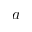Convert formula to latex. <formula><loc_0><loc_0><loc_500><loc_500>a</formula> 